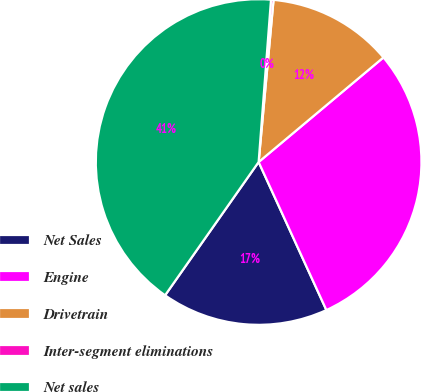<chart> <loc_0><loc_0><loc_500><loc_500><pie_chart><fcel>Net Sales<fcel>Engine<fcel>Drivetrain<fcel>Inter-segment eliminations<fcel>Net sales<nl><fcel>16.57%<fcel>29.27%<fcel>12.44%<fcel>0.25%<fcel>41.47%<nl></chart> 